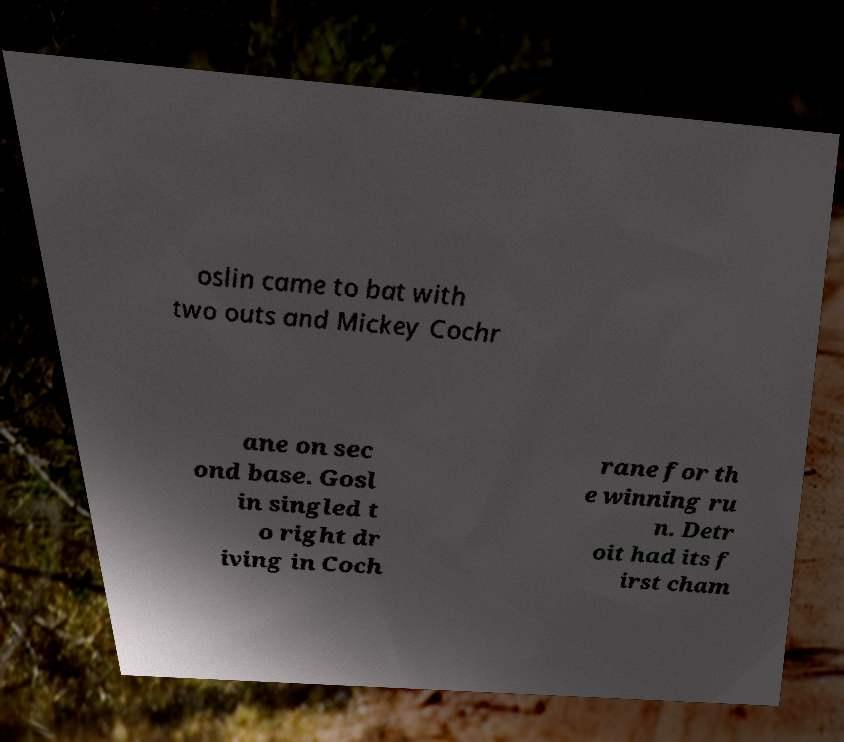There's text embedded in this image that I need extracted. Can you transcribe it verbatim? oslin came to bat with two outs and Mickey Cochr ane on sec ond base. Gosl in singled t o right dr iving in Coch rane for th e winning ru n. Detr oit had its f irst cham 